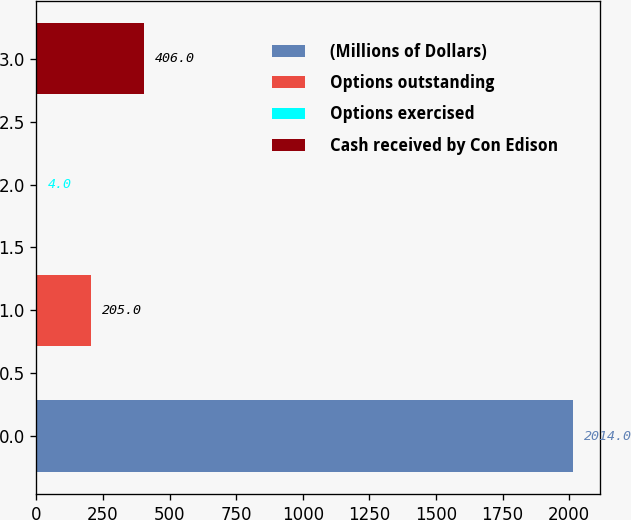Convert chart. <chart><loc_0><loc_0><loc_500><loc_500><bar_chart><fcel>(Millions of Dollars)<fcel>Options outstanding<fcel>Options exercised<fcel>Cash received by Con Edison<nl><fcel>2014<fcel>205<fcel>4<fcel>406<nl></chart> 